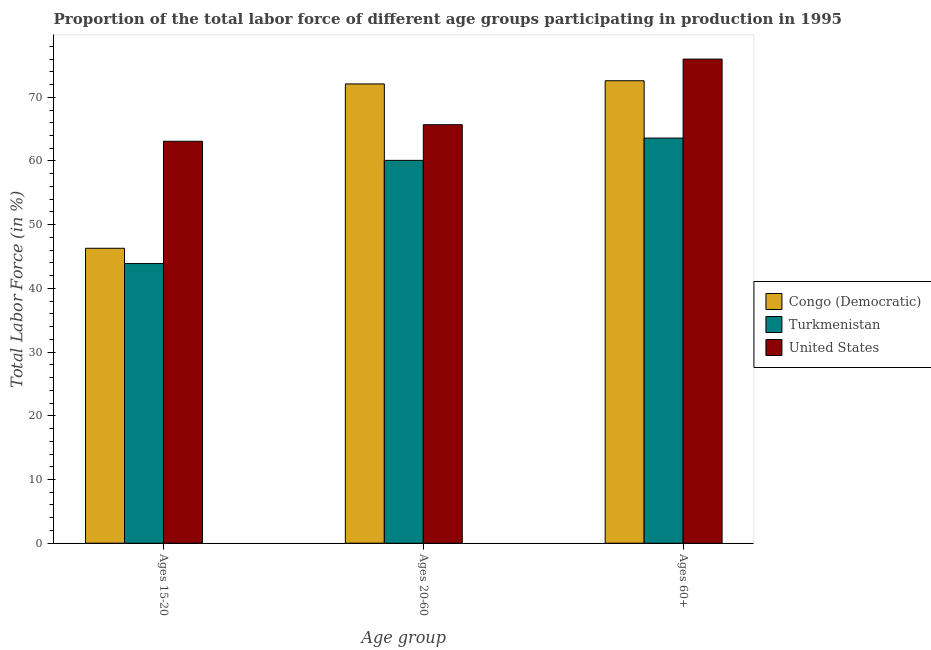Are the number of bars on each tick of the X-axis equal?
Keep it short and to the point. Yes. How many bars are there on the 2nd tick from the left?
Provide a short and direct response. 3. What is the label of the 2nd group of bars from the left?
Ensure brevity in your answer.  Ages 20-60. What is the percentage of labor force within the age group 15-20 in Turkmenistan?
Provide a short and direct response. 43.9. Across all countries, what is the maximum percentage of labor force within the age group 20-60?
Give a very brief answer. 72.1. Across all countries, what is the minimum percentage of labor force above age 60?
Make the answer very short. 63.6. In which country was the percentage of labor force within the age group 20-60 maximum?
Give a very brief answer. Congo (Democratic). In which country was the percentage of labor force within the age group 15-20 minimum?
Offer a very short reply. Turkmenistan. What is the total percentage of labor force within the age group 20-60 in the graph?
Make the answer very short. 197.9. What is the difference between the percentage of labor force within the age group 15-20 in Congo (Democratic) and that in Turkmenistan?
Your answer should be very brief. 2.4. What is the difference between the percentage of labor force within the age group 15-20 in Congo (Democratic) and the percentage of labor force above age 60 in Turkmenistan?
Provide a succinct answer. -17.3. What is the average percentage of labor force above age 60 per country?
Give a very brief answer. 70.73. What is the difference between the percentage of labor force above age 60 and percentage of labor force within the age group 20-60 in United States?
Keep it short and to the point. 10.3. In how many countries, is the percentage of labor force within the age group 20-60 greater than 10 %?
Offer a terse response. 3. What is the ratio of the percentage of labor force within the age group 15-20 in United States to that in Turkmenistan?
Offer a very short reply. 1.44. Is the difference between the percentage of labor force above age 60 in Congo (Democratic) and United States greater than the difference between the percentage of labor force within the age group 15-20 in Congo (Democratic) and United States?
Ensure brevity in your answer.  Yes. What is the difference between the highest and the second highest percentage of labor force above age 60?
Your answer should be very brief. 3.4. What is the difference between the highest and the lowest percentage of labor force within the age group 20-60?
Give a very brief answer. 12. What does the 1st bar from the left in Ages 20-60 represents?
Make the answer very short. Congo (Democratic). What does the 1st bar from the right in Ages 20-60 represents?
Your response must be concise. United States. How many bars are there?
Keep it short and to the point. 9. Are all the bars in the graph horizontal?
Offer a very short reply. No. How many countries are there in the graph?
Provide a short and direct response. 3. Are the values on the major ticks of Y-axis written in scientific E-notation?
Your response must be concise. No. Where does the legend appear in the graph?
Your response must be concise. Center right. How are the legend labels stacked?
Give a very brief answer. Vertical. What is the title of the graph?
Ensure brevity in your answer.  Proportion of the total labor force of different age groups participating in production in 1995. Does "Middle East & North Africa (all income levels)" appear as one of the legend labels in the graph?
Your answer should be compact. No. What is the label or title of the X-axis?
Offer a terse response. Age group. What is the label or title of the Y-axis?
Provide a succinct answer. Total Labor Force (in %). What is the Total Labor Force (in %) in Congo (Democratic) in Ages 15-20?
Offer a terse response. 46.3. What is the Total Labor Force (in %) of Turkmenistan in Ages 15-20?
Your response must be concise. 43.9. What is the Total Labor Force (in %) of United States in Ages 15-20?
Provide a succinct answer. 63.1. What is the Total Labor Force (in %) of Congo (Democratic) in Ages 20-60?
Your answer should be very brief. 72.1. What is the Total Labor Force (in %) in Turkmenistan in Ages 20-60?
Offer a terse response. 60.1. What is the Total Labor Force (in %) of United States in Ages 20-60?
Provide a succinct answer. 65.7. What is the Total Labor Force (in %) in Congo (Democratic) in Ages 60+?
Provide a short and direct response. 72.6. What is the Total Labor Force (in %) of Turkmenistan in Ages 60+?
Your response must be concise. 63.6. What is the Total Labor Force (in %) in United States in Ages 60+?
Provide a short and direct response. 76. Across all Age group, what is the maximum Total Labor Force (in %) in Congo (Democratic)?
Provide a short and direct response. 72.6. Across all Age group, what is the maximum Total Labor Force (in %) in Turkmenistan?
Provide a short and direct response. 63.6. Across all Age group, what is the maximum Total Labor Force (in %) of United States?
Your response must be concise. 76. Across all Age group, what is the minimum Total Labor Force (in %) of Congo (Democratic)?
Offer a very short reply. 46.3. Across all Age group, what is the minimum Total Labor Force (in %) of Turkmenistan?
Provide a short and direct response. 43.9. Across all Age group, what is the minimum Total Labor Force (in %) in United States?
Your answer should be very brief. 63.1. What is the total Total Labor Force (in %) in Congo (Democratic) in the graph?
Give a very brief answer. 191. What is the total Total Labor Force (in %) of Turkmenistan in the graph?
Provide a succinct answer. 167.6. What is the total Total Labor Force (in %) of United States in the graph?
Offer a very short reply. 204.8. What is the difference between the Total Labor Force (in %) of Congo (Democratic) in Ages 15-20 and that in Ages 20-60?
Your answer should be compact. -25.8. What is the difference between the Total Labor Force (in %) in Turkmenistan in Ages 15-20 and that in Ages 20-60?
Provide a short and direct response. -16.2. What is the difference between the Total Labor Force (in %) of United States in Ages 15-20 and that in Ages 20-60?
Your answer should be compact. -2.6. What is the difference between the Total Labor Force (in %) in Congo (Democratic) in Ages 15-20 and that in Ages 60+?
Keep it short and to the point. -26.3. What is the difference between the Total Labor Force (in %) of Turkmenistan in Ages 15-20 and that in Ages 60+?
Your response must be concise. -19.7. What is the difference between the Total Labor Force (in %) of Turkmenistan in Ages 20-60 and that in Ages 60+?
Offer a terse response. -3.5. What is the difference between the Total Labor Force (in %) in United States in Ages 20-60 and that in Ages 60+?
Give a very brief answer. -10.3. What is the difference between the Total Labor Force (in %) of Congo (Democratic) in Ages 15-20 and the Total Labor Force (in %) of United States in Ages 20-60?
Ensure brevity in your answer.  -19.4. What is the difference between the Total Labor Force (in %) of Turkmenistan in Ages 15-20 and the Total Labor Force (in %) of United States in Ages 20-60?
Keep it short and to the point. -21.8. What is the difference between the Total Labor Force (in %) in Congo (Democratic) in Ages 15-20 and the Total Labor Force (in %) in Turkmenistan in Ages 60+?
Your response must be concise. -17.3. What is the difference between the Total Labor Force (in %) in Congo (Democratic) in Ages 15-20 and the Total Labor Force (in %) in United States in Ages 60+?
Your answer should be compact. -29.7. What is the difference between the Total Labor Force (in %) in Turkmenistan in Ages 15-20 and the Total Labor Force (in %) in United States in Ages 60+?
Offer a terse response. -32.1. What is the difference between the Total Labor Force (in %) of Congo (Democratic) in Ages 20-60 and the Total Labor Force (in %) of Turkmenistan in Ages 60+?
Ensure brevity in your answer.  8.5. What is the difference between the Total Labor Force (in %) of Congo (Democratic) in Ages 20-60 and the Total Labor Force (in %) of United States in Ages 60+?
Offer a very short reply. -3.9. What is the difference between the Total Labor Force (in %) in Turkmenistan in Ages 20-60 and the Total Labor Force (in %) in United States in Ages 60+?
Keep it short and to the point. -15.9. What is the average Total Labor Force (in %) in Congo (Democratic) per Age group?
Give a very brief answer. 63.67. What is the average Total Labor Force (in %) in Turkmenistan per Age group?
Your response must be concise. 55.87. What is the average Total Labor Force (in %) of United States per Age group?
Give a very brief answer. 68.27. What is the difference between the Total Labor Force (in %) of Congo (Democratic) and Total Labor Force (in %) of Turkmenistan in Ages 15-20?
Offer a terse response. 2.4. What is the difference between the Total Labor Force (in %) of Congo (Democratic) and Total Labor Force (in %) of United States in Ages 15-20?
Your answer should be very brief. -16.8. What is the difference between the Total Labor Force (in %) in Turkmenistan and Total Labor Force (in %) in United States in Ages 15-20?
Provide a succinct answer. -19.2. What is the difference between the Total Labor Force (in %) of Congo (Democratic) and Total Labor Force (in %) of Turkmenistan in Ages 20-60?
Ensure brevity in your answer.  12. What is the difference between the Total Labor Force (in %) in Turkmenistan and Total Labor Force (in %) in United States in Ages 20-60?
Give a very brief answer. -5.6. What is the difference between the Total Labor Force (in %) in Congo (Democratic) and Total Labor Force (in %) in Turkmenistan in Ages 60+?
Provide a short and direct response. 9. What is the difference between the Total Labor Force (in %) in Turkmenistan and Total Labor Force (in %) in United States in Ages 60+?
Offer a terse response. -12.4. What is the ratio of the Total Labor Force (in %) in Congo (Democratic) in Ages 15-20 to that in Ages 20-60?
Offer a very short reply. 0.64. What is the ratio of the Total Labor Force (in %) of Turkmenistan in Ages 15-20 to that in Ages 20-60?
Offer a terse response. 0.73. What is the ratio of the Total Labor Force (in %) in United States in Ages 15-20 to that in Ages 20-60?
Your answer should be compact. 0.96. What is the ratio of the Total Labor Force (in %) in Congo (Democratic) in Ages 15-20 to that in Ages 60+?
Make the answer very short. 0.64. What is the ratio of the Total Labor Force (in %) of Turkmenistan in Ages 15-20 to that in Ages 60+?
Your answer should be very brief. 0.69. What is the ratio of the Total Labor Force (in %) of United States in Ages 15-20 to that in Ages 60+?
Offer a terse response. 0.83. What is the ratio of the Total Labor Force (in %) in Congo (Democratic) in Ages 20-60 to that in Ages 60+?
Offer a terse response. 0.99. What is the ratio of the Total Labor Force (in %) in Turkmenistan in Ages 20-60 to that in Ages 60+?
Keep it short and to the point. 0.94. What is the ratio of the Total Labor Force (in %) of United States in Ages 20-60 to that in Ages 60+?
Keep it short and to the point. 0.86. What is the difference between the highest and the second highest Total Labor Force (in %) of Turkmenistan?
Make the answer very short. 3.5. What is the difference between the highest and the lowest Total Labor Force (in %) of Congo (Democratic)?
Provide a short and direct response. 26.3. What is the difference between the highest and the lowest Total Labor Force (in %) of Turkmenistan?
Provide a short and direct response. 19.7. 